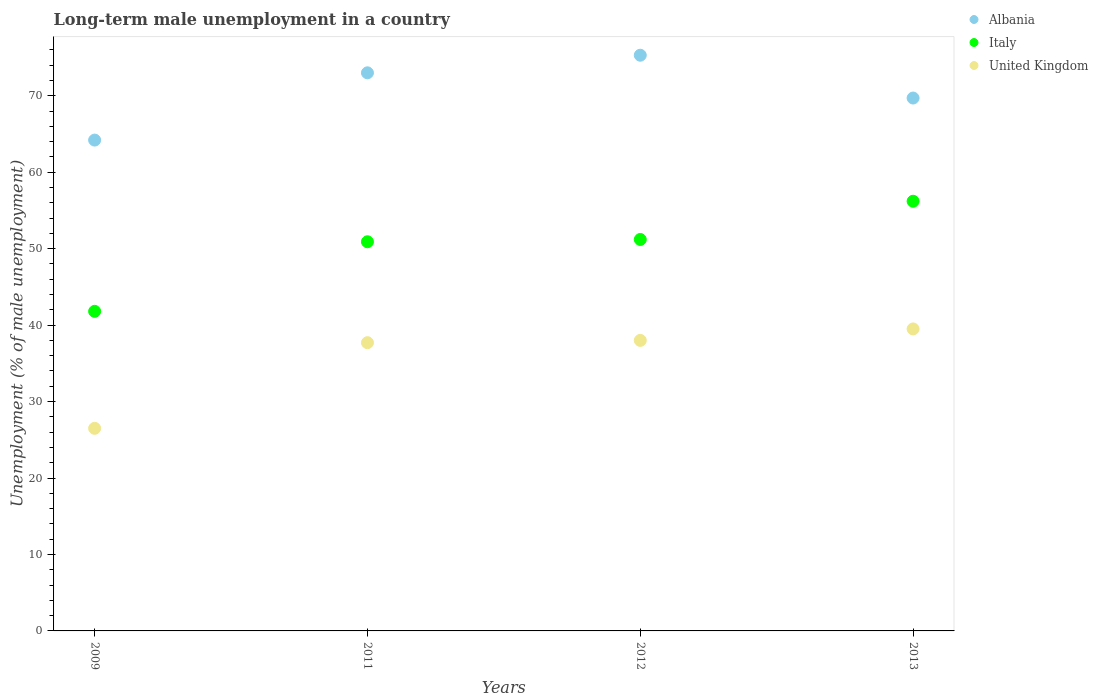How many different coloured dotlines are there?
Ensure brevity in your answer.  3. Is the number of dotlines equal to the number of legend labels?
Give a very brief answer. Yes. What is the percentage of long-term unemployed male population in Albania in 2013?
Give a very brief answer. 69.7. Across all years, what is the maximum percentage of long-term unemployed male population in United Kingdom?
Make the answer very short. 39.5. Across all years, what is the minimum percentage of long-term unemployed male population in Albania?
Offer a terse response. 64.2. In which year was the percentage of long-term unemployed male population in Albania maximum?
Your response must be concise. 2012. What is the total percentage of long-term unemployed male population in Italy in the graph?
Your response must be concise. 200.1. What is the difference between the percentage of long-term unemployed male population in Italy in 2013 and the percentage of long-term unemployed male population in United Kingdom in 2009?
Give a very brief answer. 29.7. What is the average percentage of long-term unemployed male population in Albania per year?
Provide a short and direct response. 70.55. In the year 2011, what is the difference between the percentage of long-term unemployed male population in United Kingdom and percentage of long-term unemployed male population in Italy?
Give a very brief answer. -13.2. What is the ratio of the percentage of long-term unemployed male population in United Kingdom in 2011 to that in 2012?
Provide a succinct answer. 0.99. Is the difference between the percentage of long-term unemployed male population in United Kingdom in 2011 and 2013 greater than the difference between the percentage of long-term unemployed male population in Italy in 2011 and 2013?
Make the answer very short. Yes. What is the difference between the highest and the second highest percentage of long-term unemployed male population in United Kingdom?
Provide a succinct answer. 1.5. What is the difference between the highest and the lowest percentage of long-term unemployed male population in Albania?
Ensure brevity in your answer.  11.1. Is it the case that in every year, the sum of the percentage of long-term unemployed male population in Italy and percentage of long-term unemployed male population in Albania  is greater than the percentage of long-term unemployed male population in United Kingdom?
Provide a succinct answer. Yes. Is the percentage of long-term unemployed male population in United Kingdom strictly greater than the percentage of long-term unemployed male population in Italy over the years?
Offer a very short reply. No. Is the percentage of long-term unemployed male population in Albania strictly less than the percentage of long-term unemployed male population in Italy over the years?
Provide a short and direct response. No. How many dotlines are there?
Give a very brief answer. 3. Are the values on the major ticks of Y-axis written in scientific E-notation?
Give a very brief answer. No. Does the graph contain any zero values?
Provide a short and direct response. No. Where does the legend appear in the graph?
Keep it short and to the point. Top right. How are the legend labels stacked?
Offer a very short reply. Vertical. What is the title of the graph?
Provide a short and direct response. Long-term male unemployment in a country. What is the label or title of the Y-axis?
Your response must be concise. Unemployment (% of male unemployment). What is the Unemployment (% of male unemployment) of Albania in 2009?
Your answer should be very brief. 64.2. What is the Unemployment (% of male unemployment) of Italy in 2009?
Provide a succinct answer. 41.8. What is the Unemployment (% of male unemployment) of Albania in 2011?
Your response must be concise. 73. What is the Unemployment (% of male unemployment) in Italy in 2011?
Ensure brevity in your answer.  50.9. What is the Unemployment (% of male unemployment) of United Kingdom in 2011?
Your answer should be compact. 37.7. What is the Unemployment (% of male unemployment) of Albania in 2012?
Make the answer very short. 75.3. What is the Unemployment (% of male unemployment) in Italy in 2012?
Keep it short and to the point. 51.2. What is the Unemployment (% of male unemployment) in Albania in 2013?
Offer a very short reply. 69.7. What is the Unemployment (% of male unemployment) of Italy in 2013?
Your response must be concise. 56.2. What is the Unemployment (% of male unemployment) of United Kingdom in 2013?
Ensure brevity in your answer.  39.5. Across all years, what is the maximum Unemployment (% of male unemployment) of Albania?
Keep it short and to the point. 75.3. Across all years, what is the maximum Unemployment (% of male unemployment) of Italy?
Your answer should be compact. 56.2. Across all years, what is the maximum Unemployment (% of male unemployment) of United Kingdom?
Give a very brief answer. 39.5. Across all years, what is the minimum Unemployment (% of male unemployment) in Albania?
Your response must be concise. 64.2. Across all years, what is the minimum Unemployment (% of male unemployment) of Italy?
Ensure brevity in your answer.  41.8. Across all years, what is the minimum Unemployment (% of male unemployment) in United Kingdom?
Ensure brevity in your answer.  26.5. What is the total Unemployment (% of male unemployment) of Albania in the graph?
Provide a succinct answer. 282.2. What is the total Unemployment (% of male unemployment) of Italy in the graph?
Make the answer very short. 200.1. What is the total Unemployment (% of male unemployment) of United Kingdom in the graph?
Offer a terse response. 141.7. What is the difference between the Unemployment (% of male unemployment) of Italy in 2009 and that in 2011?
Your answer should be very brief. -9.1. What is the difference between the Unemployment (% of male unemployment) of United Kingdom in 2009 and that in 2011?
Your response must be concise. -11.2. What is the difference between the Unemployment (% of male unemployment) in Albania in 2009 and that in 2012?
Ensure brevity in your answer.  -11.1. What is the difference between the Unemployment (% of male unemployment) in Albania in 2009 and that in 2013?
Your response must be concise. -5.5. What is the difference between the Unemployment (% of male unemployment) in Italy in 2009 and that in 2013?
Make the answer very short. -14.4. What is the difference between the Unemployment (% of male unemployment) of Albania in 2011 and that in 2012?
Keep it short and to the point. -2.3. What is the difference between the Unemployment (% of male unemployment) in Italy in 2011 and that in 2012?
Your response must be concise. -0.3. What is the difference between the Unemployment (% of male unemployment) in Albania in 2011 and that in 2013?
Provide a short and direct response. 3.3. What is the difference between the Unemployment (% of male unemployment) of Italy in 2011 and that in 2013?
Give a very brief answer. -5.3. What is the difference between the Unemployment (% of male unemployment) of Italy in 2009 and the Unemployment (% of male unemployment) of United Kingdom in 2011?
Offer a terse response. 4.1. What is the difference between the Unemployment (% of male unemployment) of Albania in 2009 and the Unemployment (% of male unemployment) of United Kingdom in 2012?
Make the answer very short. 26.2. What is the difference between the Unemployment (% of male unemployment) in Italy in 2009 and the Unemployment (% of male unemployment) in United Kingdom in 2012?
Your answer should be very brief. 3.8. What is the difference between the Unemployment (% of male unemployment) of Albania in 2009 and the Unemployment (% of male unemployment) of United Kingdom in 2013?
Your response must be concise. 24.7. What is the difference between the Unemployment (% of male unemployment) of Italy in 2009 and the Unemployment (% of male unemployment) of United Kingdom in 2013?
Your response must be concise. 2.3. What is the difference between the Unemployment (% of male unemployment) in Albania in 2011 and the Unemployment (% of male unemployment) in Italy in 2012?
Keep it short and to the point. 21.8. What is the difference between the Unemployment (% of male unemployment) of Albania in 2011 and the Unemployment (% of male unemployment) of United Kingdom in 2012?
Offer a very short reply. 35. What is the difference between the Unemployment (% of male unemployment) in Italy in 2011 and the Unemployment (% of male unemployment) in United Kingdom in 2012?
Your answer should be very brief. 12.9. What is the difference between the Unemployment (% of male unemployment) in Albania in 2011 and the Unemployment (% of male unemployment) in Italy in 2013?
Offer a terse response. 16.8. What is the difference between the Unemployment (% of male unemployment) of Albania in 2011 and the Unemployment (% of male unemployment) of United Kingdom in 2013?
Offer a very short reply. 33.5. What is the difference between the Unemployment (% of male unemployment) of Albania in 2012 and the Unemployment (% of male unemployment) of Italy in 2013?
Ensure brevity in your answer.  19.1. What is the difference between the Unemployment (% of male unemployment) of Albania in 2012 and the Unemployment (% of male unemployment) of United Kingdom in 2013?
Offer a terse response. 35.8. What is the average Unemployment (% of male unemployment) of Albania per year?
Make the answer very short. 70.55. What is the average Unemployment (% of male unemployment) of Italy per year?
Offer a terse response. 50.02. What is the average Unemployment (% of male unemployment) in United Kingdom per year?
Give a very brief answer. 35.42. In the year 2009, what is the difference between the Unemployment (% of male unemployment) in Albania and Unemployment (% of male unemployment) in Italy?
Keep it short and to the point. 22.4. In the year 2009, what is the difference between the Unemployment (% of male unemployment) of Albania and Unemployment (% of male unemployment) of United Kingdom?
Make the answer very short. 37.7. In the year 2011, what is the difference between the Unemployment (% of male unemployment) of Albania and Unemployment (% of male unemployment) of Italy?
Your answer should be compact. 22.1. In the year 2011, what is the difference between the Unemployment (% of male unemployment) of Albania and Unemployment (% of male unemployment) of United Kingdom?
Provide a succinct answer. 35.3. In the year 2011, what is the difference between the Unemployment (% of male unemployment) in Italy and Unemployment (% of male unemployment) in United Kingdom?
Your answer should be compact. 13.2. In the year 2012, what is the difference between the Unemployment (% of male unemployment) of Albania and Unemployment (% of male unemployment) of Italy?
Ensure brevity in your answer.  24.1. In the year 2012, what is the difference between the Unemployment (% of male unemployment) in Albania and Unemployment (% of male unemployment) in United Kingdom?
Provide a succinct answer. 37.3. In the year 2013, what is the difference between the Unemployment (% of male unemployment) in Albania and Unemployment (% of male unemployment) in United Kingdom?
Give a very brief answer. 30.2. In the year 2013, what is the difference between the Unemployment (% of male unemployment) of Italy and Unemployment (% of male unemployment) of United Kingdom?
Provide a short and direct response. 16.7. What is the ratio of the Unemployment (% of male unemployment) in Albania in 2009 to that in 2011?
Give a very brief answer. 0.88. What is the ratio of the Unemployment (% of male unemployment) of Italy in 2009 to that in 2011?
Offer a very short reply. 0.82. What is the ratio of the Unemployment (% of male unemployment) of United Kingdom in 2009 to that in 2011?
Make the answer very short. 0.7. What is the ratio of the Unemployment (% of male unemployment) in Albania in 2009 to that in 2012?
Your answer should be compact. 0.85. What is the ratio of the Unemployment (% of male unemployment) of Italy in 2009 to that in 2012?
Offer a terse response. 0.82. What is the ratio of the Unemployment (% of male unemployment) in United Kingdom in 2009 to that in 2012?
Offer a terse response. 0.7. What is the ratio of the Unemployment (% of male unemployment) in Albania in 2009 to that in 2013?
Offer a very short reply. 0.92. What is the ratio of the Unemployment (% of male unemployment) of Italy in 2009 to that in 2013?
Provide a short and direct response. 0.74. What is the ratio of the Unemployment (% of male unemployment) in United Kingdom in 2009 to that in 2013?
Make the answer very short. 0.67. What is the ratio of the Unemployment (% of male unemployment) of Albania in 2011 to that in 2012?
Make the answer very short. 0.97. What is the ratio of the Unemployment (% of male unemployment) of Italy in 2011 to that in 2012?
Provide a succinct answer. 0.99. What is the ratio of the Unemployment (% of male unemployment) in Albania in 2011 to that in 2013?
Provide a short and direct response. 1.05. What is the ratio of the Unemployment (% of male unemployment) in Italy in 2011 to that in 2013?
Offer a terse response. 0.91. What is the ratio of the Unemployment (% of male unemployment) in United Kingdom in 2011 to that in 2013?
Offer a very short reply. 0.95. What is the ratio of the Unemployment (% of male unemployment) in Albania in 2012 to that in 2013?
Your answer should be very brief. 1.08. What is the ratio of the Unemployment (% of male unemployment) in Italy in 2012 to that in 2013?
Make the answer very short. 0.91. What is the difference between the highest and the second highest Unemployment (% of male unemployment) of Albania?
Make the answer very short. 2.3. 